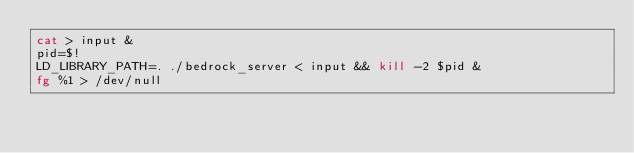Convert code to text. <code><loc_0><loc_0><loc_500><loc_500><_Bash_>cat > input &
pid=$!
LD_LIBRARY_PATH=. ./bedrock_server < input && kill -2 $pid &
fg %1 > /dev/null
</code> 